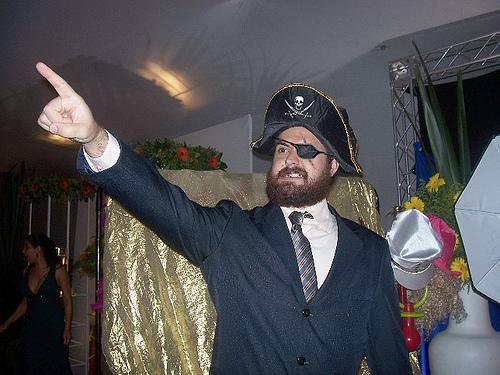If you had to guess which holiday would this most likely be?

Choices:
A) thanksgiving
B) christmas
C) new years
D) halloween halloween 